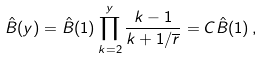<formula> <loc_0><loc_0><loc_500><loc_500>\hat { B } ( y ) = \hat { B } ( 1 ) \prod _ { k = 2 } ^ { y } \frac { k - 1 } { k + 1 / \overline { r } } = C \hat { B } ( 1 ) \, ,</formula> 